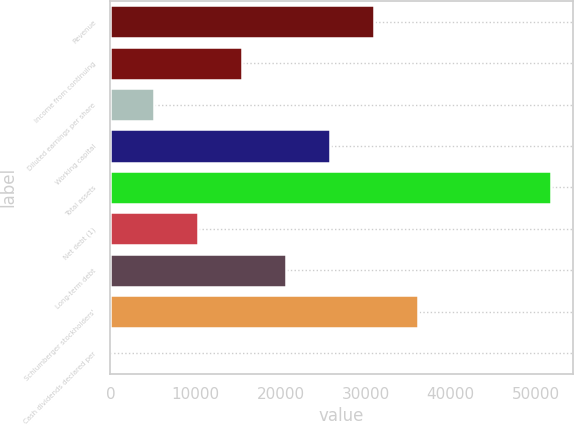<chart> <loc_0><loc_0><loc_500><loc_500><bar_chart><fcel>Revenue<fcel>Income from continuing<fcel>Diluted earnings per share<fcel>Working capital<fcel>Total assets<fcel>Net debt (1)<fcel>Long-term debt<fcel>Schlumberger stockholders'<fcel>Cash dividends declared per<nl><fcel>31060.6<fcel>15530.7<fcel>5177.46<fcel>25883.9<fcel>51767<fcel>10354.1<fcel>20707.3<fcel>36237.2<fcel>0.84<nl></chart> 